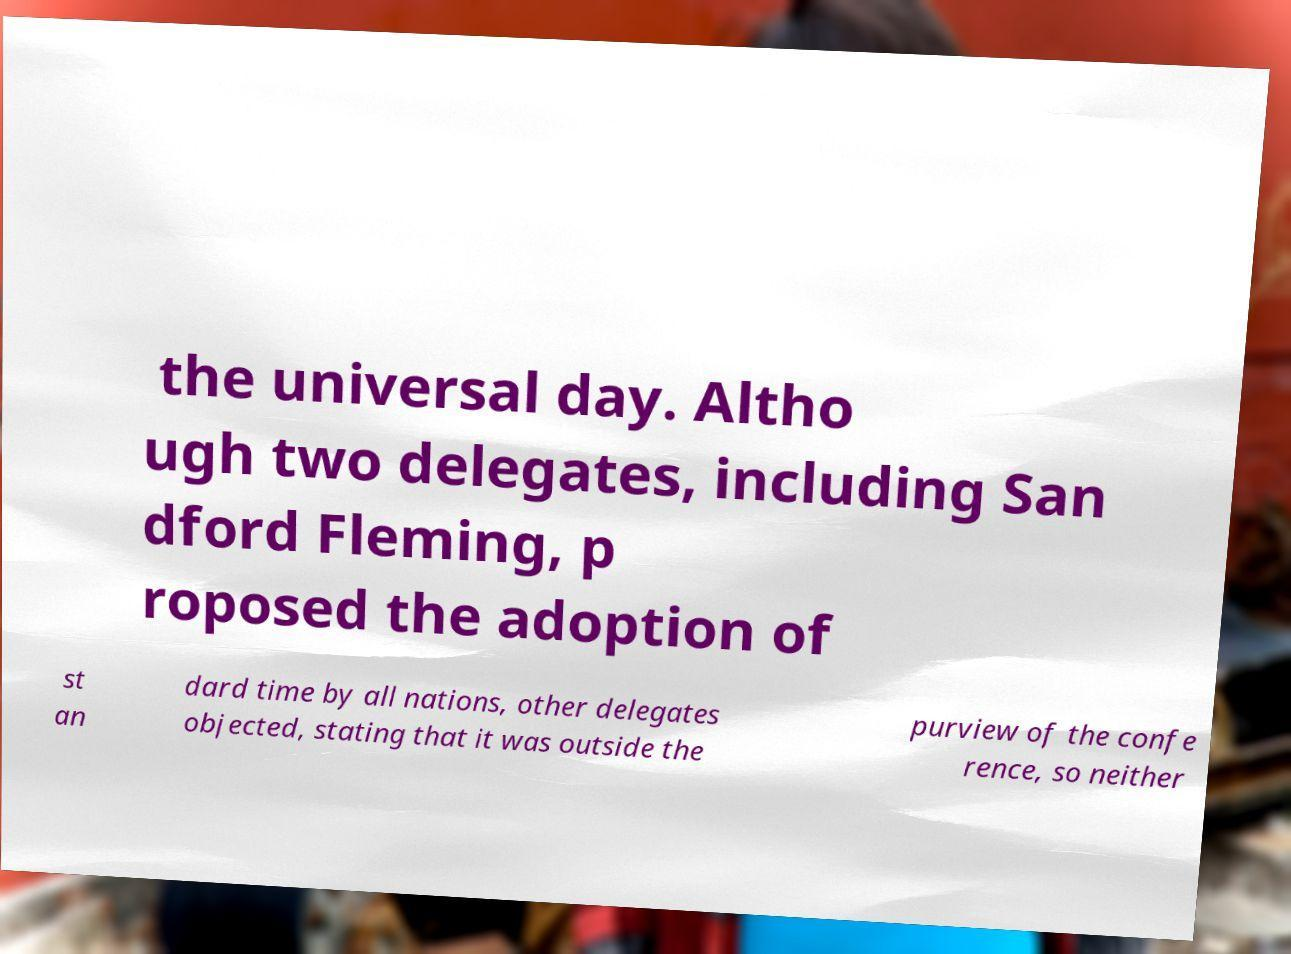Please identify and transcribe the text found in this image. the universal day. Altho ugh two delegates, including San dford Fleming, p roposed the adoption of st an dard time by all nations, other delegates objected, stating that it was outside the purview of the confe rence, so neither 